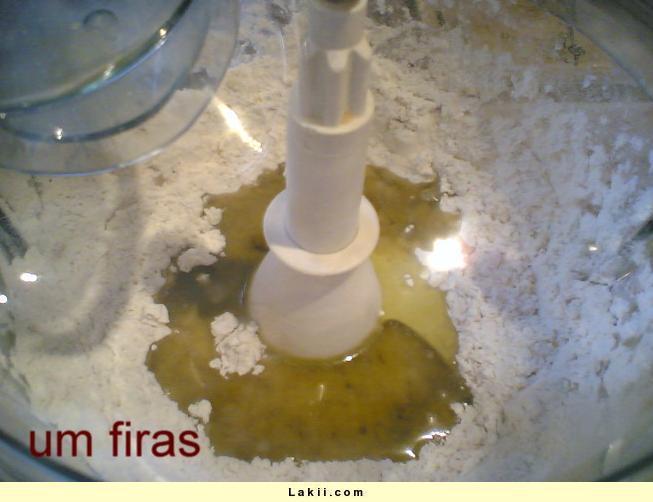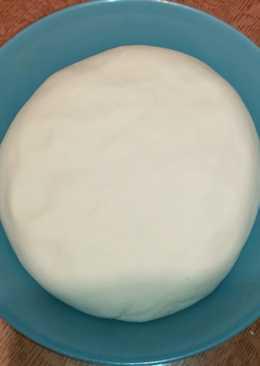The first image is the image on the left, the second image is the image on the right. Evaluate the accuracy of this statement regarding the images: "The images show two different stages of dough in a mixer.". Is it true? Answer yes or no. No. 